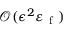<formula> <loc_0><loc_0><loc_500><loc_500>\mathcal { O } ( \epsilon ^ { 2 } \varepsilon _ { f } )</formula> 